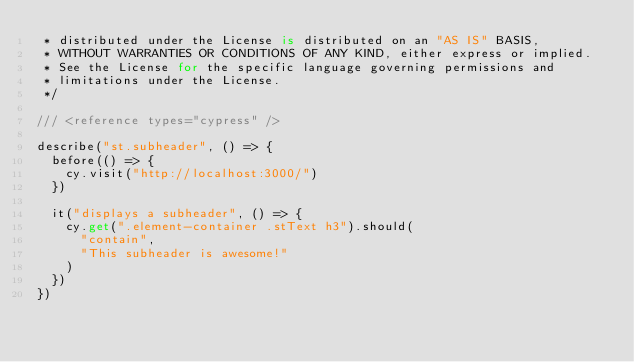<code> <loc_0><loc_0><loc_500><loc_500><_TypeScript_> * distributed under the License is distributed on an "AS IS" BASIS,
 * WITHOUT WARRANTIES OR CONDITIONS OF ANY KIND, either express or implied.
 * See the License for the specific language governing permissions and
 * limitations under the License.
 */

/// <reference types="cypress" />

describe("st.subheader", () => {
  before(() => {
    cy.visit("http://localhost:3000/")
  })

  it("displays a subheader", () => {
    cy.get(".element-container .stText h3").should(
      "contain",
      "This subheader is awesome!"
    )
  })
})
</code> 